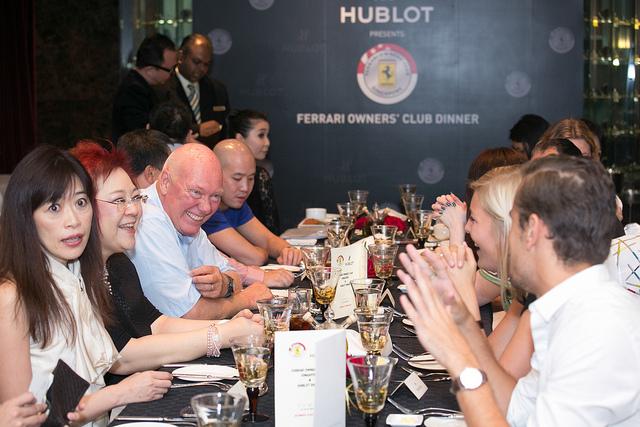Does this gathering look noisy?
Give a very brief answer. Yes. What type of car are these people interested in?
Keep it brief. Ferrari. How many people are in the image?
Give a very brief answer. 14. 